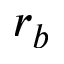<formula> <loc_0><loc_0><loc_500><loc_500>r _ { b }</formula> 